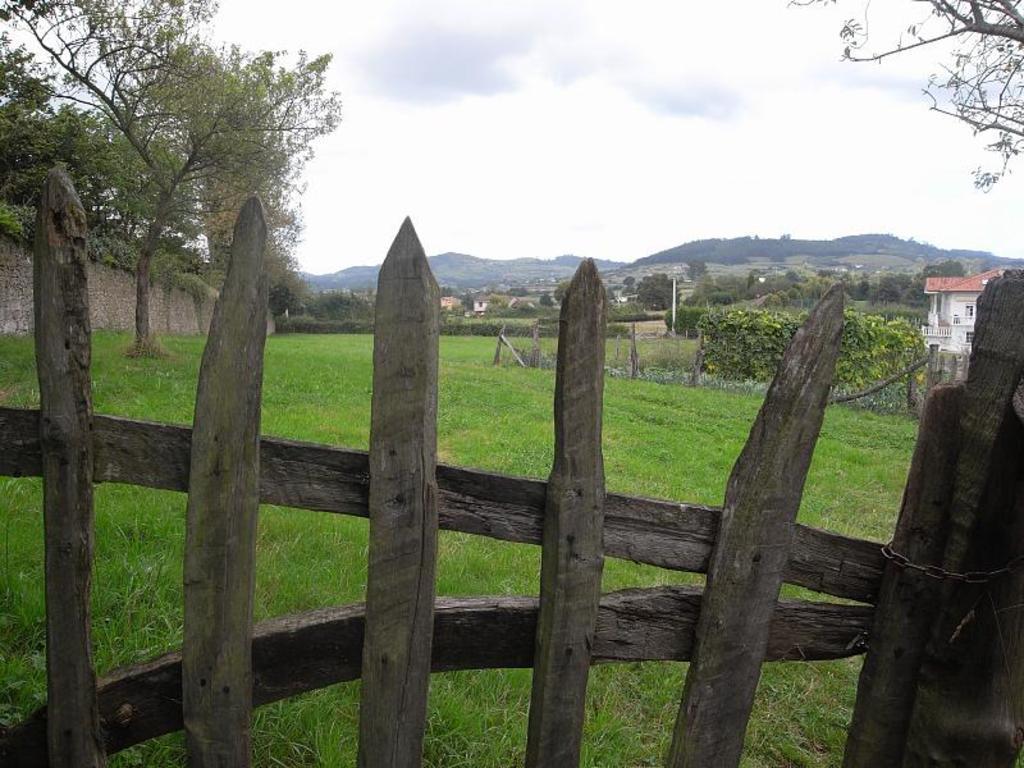Please provide a concise description of this image. In this image, I can see a wooden fence and grass. In the background, there are trees, houses, hills, plants, a wall and the sky. 